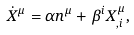Convert formula to latex. <formula><loc_0><loc_0><loc_500><loc_500>\dot { X } ^ { \mu } = \alpha n ^ { \mu } + \beta ^ { i } X ^ { \mu } _ { , i } ,</formula> 